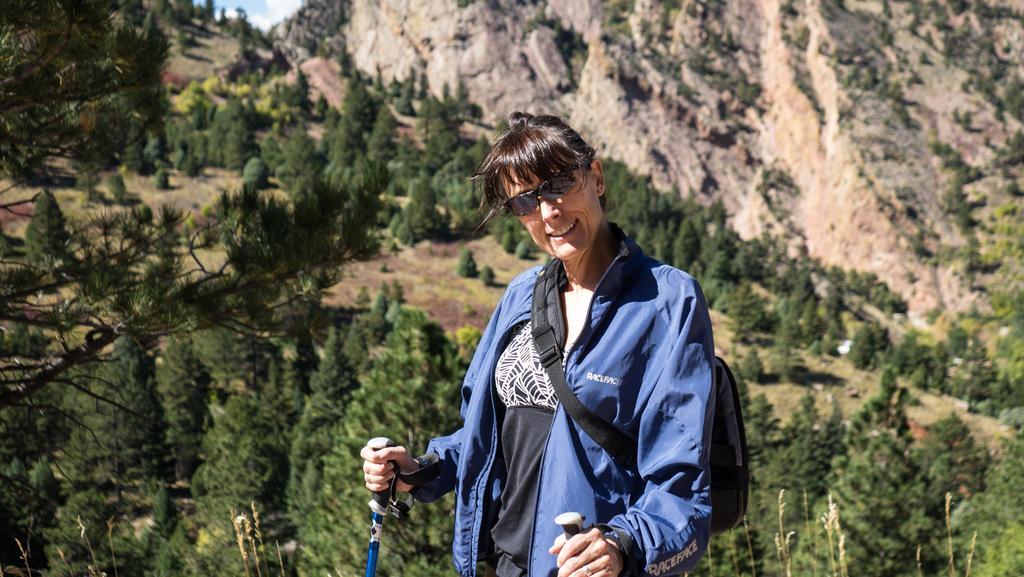How would you summarize this image in a sentence or two? Here in this picture we can see a woman standing over a place and we can see she is holding sticks in her hand and wearing a jacket and carrying a bag and we can also see she is wearing goggles and smiling and behind her we can see mountains, that are covered with grass, plants and trees and we can see clouds in the sky. 